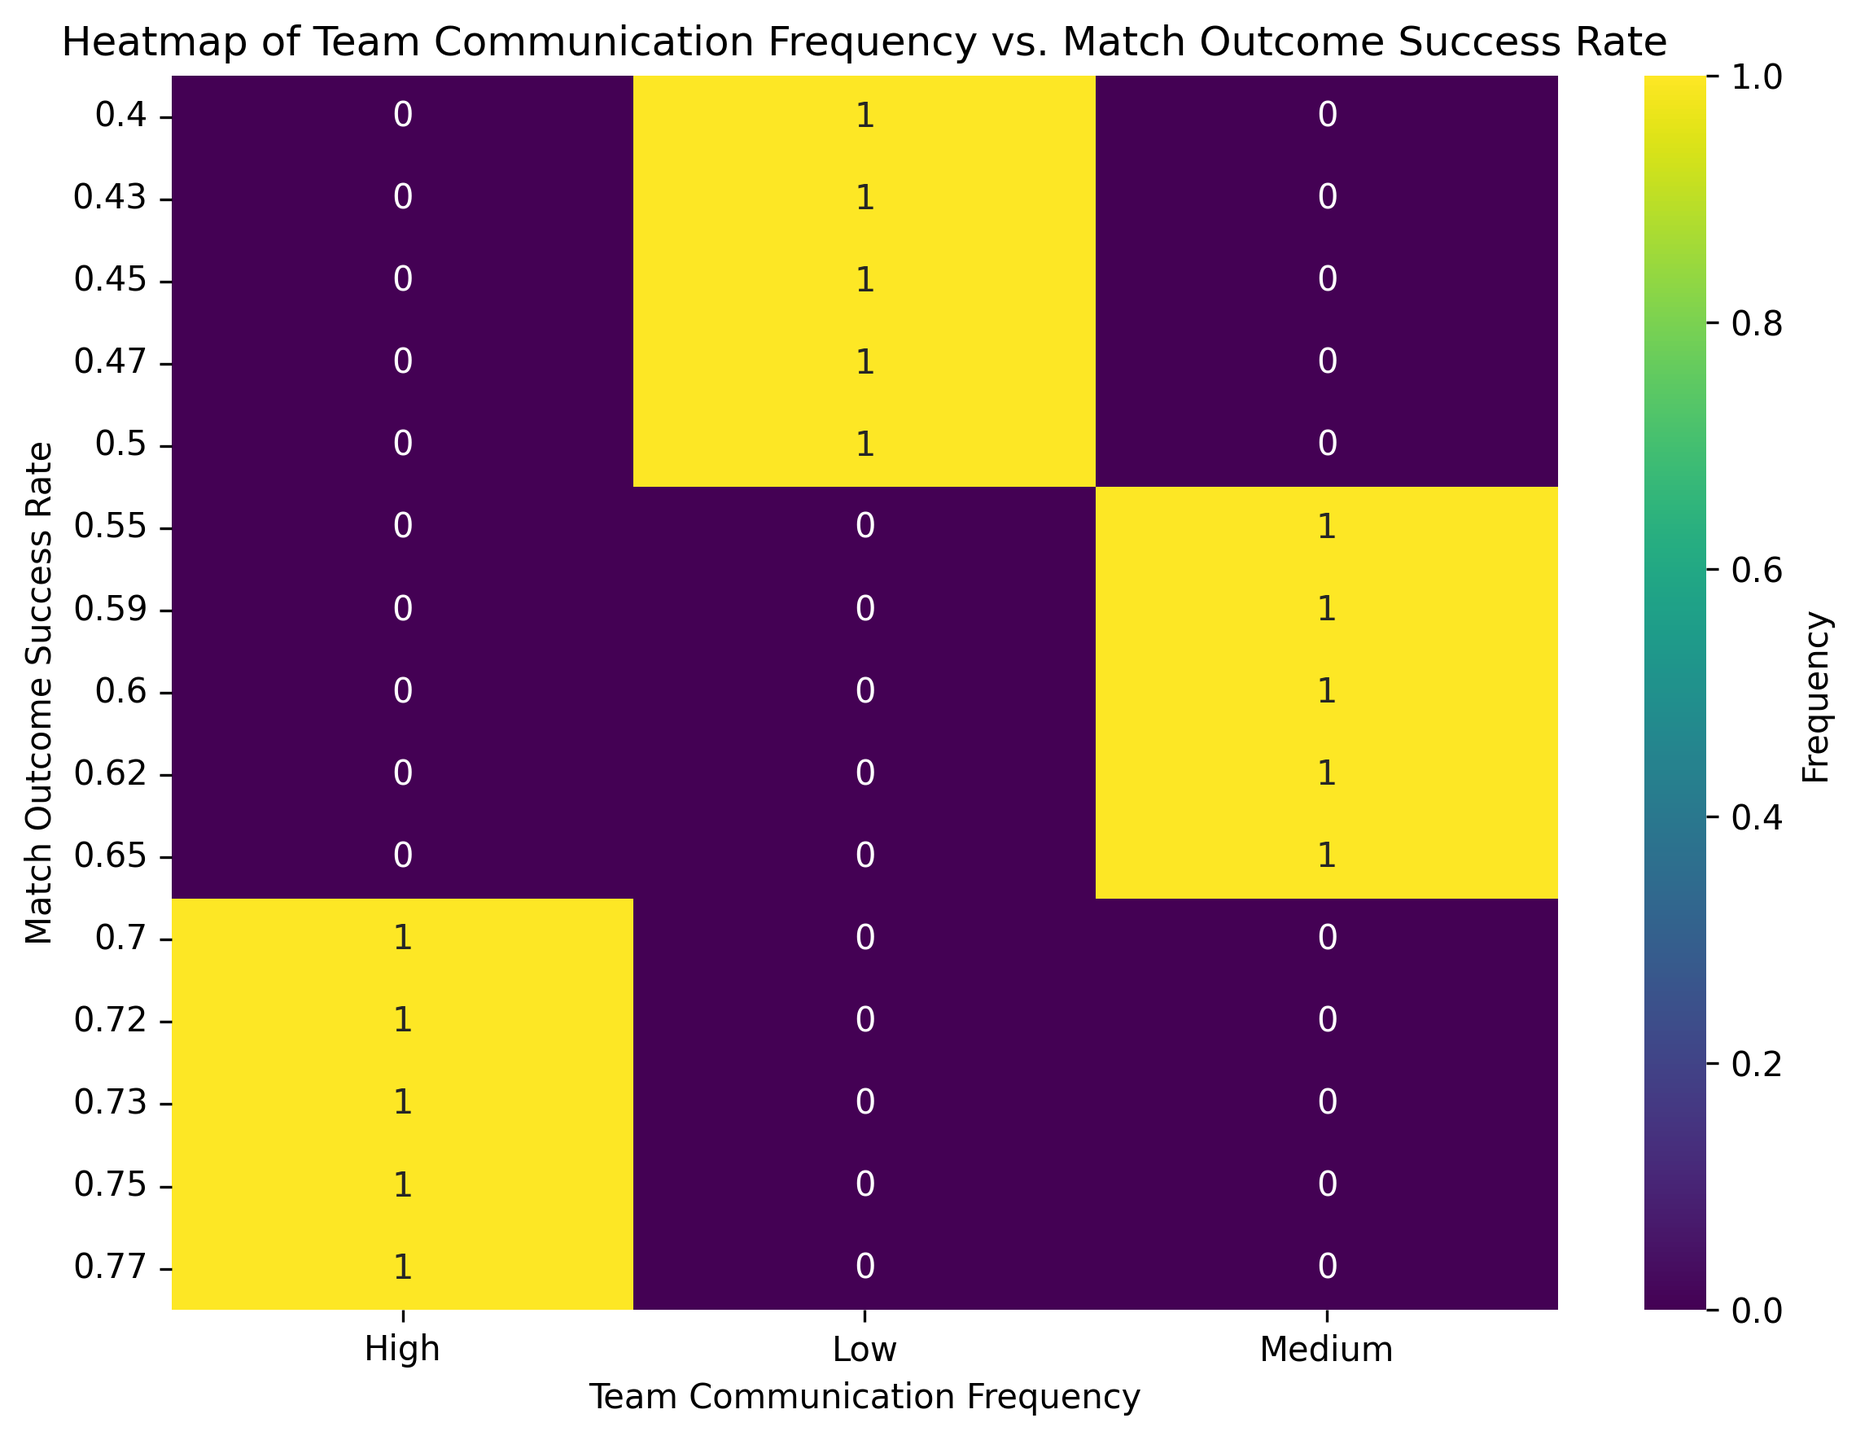What's the highest Match Outcome Success Rate observed with Low Team Communication Frequency? To find the highest Match Outcome Success Rate with Low Team Communication Frequency, locate the region marked 'Low' on the x-axis and find the highest value on the y-axis within this region. The highest observed rate is 0.50.
Answer: 0.50 Which Team Communication Frequency group shows the highest success rate for matches? Look at the regions marked 'Low', 'Medium', and 'High' on the x-axis and identify the highest Match Outcome Success Rate across all these groups. The 'High' group has the highest success rate of 0.77.
Answer: High How does the Match Outcome Success Rate change as Team Communication Frequency increases from Low to High? Observe the trend from the 'Low' region on the x-axis through 'Medium’ to 'High'. The success rate generally increases: Low (up to 0.50), Medium (up to 0.65), and High (up to 0.77).
Answer: Increases What is the average Match Outcome Success Rate for the Medium Team Communication Frequency group? Identify all success rates in the 'Medium' region of the plot. Sum the values (0.60 + 0.62 + 0.65 + 0.55 + 0.59 = 3.01) and divide by the number of observations (5) to get the average. 3.01 / 5 = 0.602
Answer: 0.602 Compare the most frequent Match Outcome Success Rate in the Low and High Team Communication Frequency groups. For the 'Low' and 'High' regions on the x-axis, count the occurrences of each Match Outcome Success Rate value. The most frequent rate for 'Low' is 0.45 (1 occurrence) and for 'High' is 0.75 (1 occurrence). Since both are equally frequent, compare their success rates: 0.75 is higher.
Answer: 0.75 What is the total number of observations for Low Team Communication Frequency? Find the total count of data points in the 'Low' column. Summing all the counts, there are 5 observations.
Answer: 5 What visual pattern can you observe regarding the distribution of Match Outcome Success Rates across different levels of Team Communication Frequency? Observe the distribution of success rates. The rates for 'Low' are in a lower range (up to 0.50), for 'Medium' in middle (up to 0.65), and for 'High' in a higher range (up to 0.77), indicating a positive trend between communication frequency and success rate.
Answer: Positive trend 